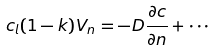<formula> <loc_0><loc_0><loc_500><loc_500>c _ { l } ( 1 - k ) V _ { n } = - D \frac { \partial c } { \partial n } + \cdots</formula> 